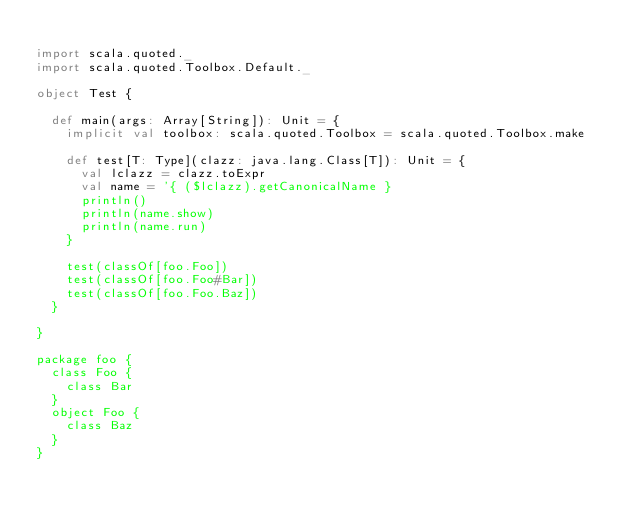<code> <loc_0><loc_0><loc_500><loc_500><_Scala_>
import scala.quoted._
import scala.quoted.Toolbox.Default._

object Test {

  def main(args: Array[String]): Unit = {
    implicit val toolbox: scala.quoted.Toolbox = scala.quoted.Toolbox.make

    def test[T: Type](clazz: java.lang.Class[T]): Unit = {
      val lclazz = clazz.toExpr
      val name = '{ ($lclazz).getCanonicalName }
      println()
      println(name.show)
      println(name.run)
    }

    test(classOf[foo.Foo])
    test(classOf[foo.Foo#Bar])
    test(classOf[foo.Foo.Baz])
  }

}

package foo {
  class Foo {
    class Bar
  }
  object Foo {
    class Baz
  }
}
</code> 